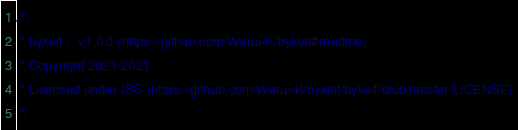Convert code to text. <code><loc_0><loc_0><loc_500><loc_500><_JavaScript_>/*!
 * bykeit -  v1.0.0 (https://github.com/Warui-K/bykeit#readme)
 * Copyright 2021-2021 
 * Licensed under ISC (https://github.com/Warui-K/bykeit/bykeit/blob/master/LICENSE)
 */
</code> 